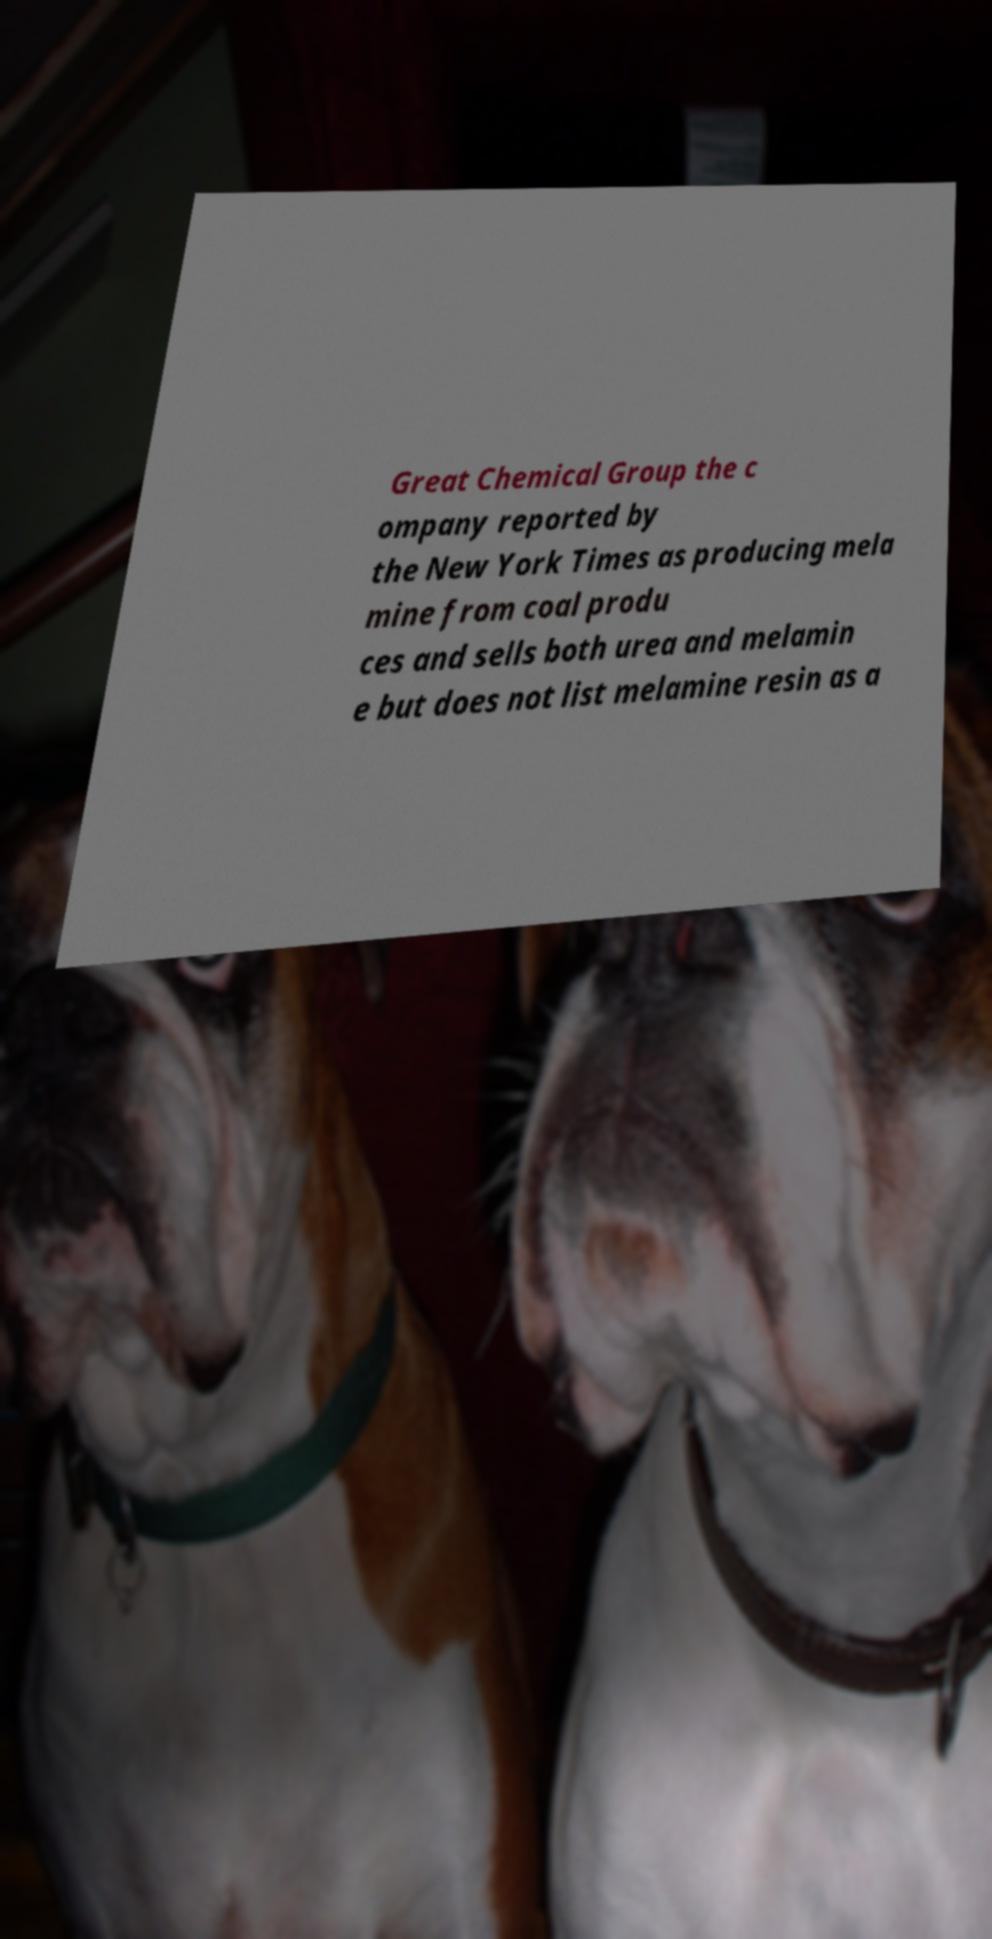For documentation purposes, I need the text within this image transcribed. Could you provide that? Great Chemical Group the c ompany reported by the New York Times as producing mela mine from coal produ ces and sells both urea and melamin e but does not list melamine resin as a 